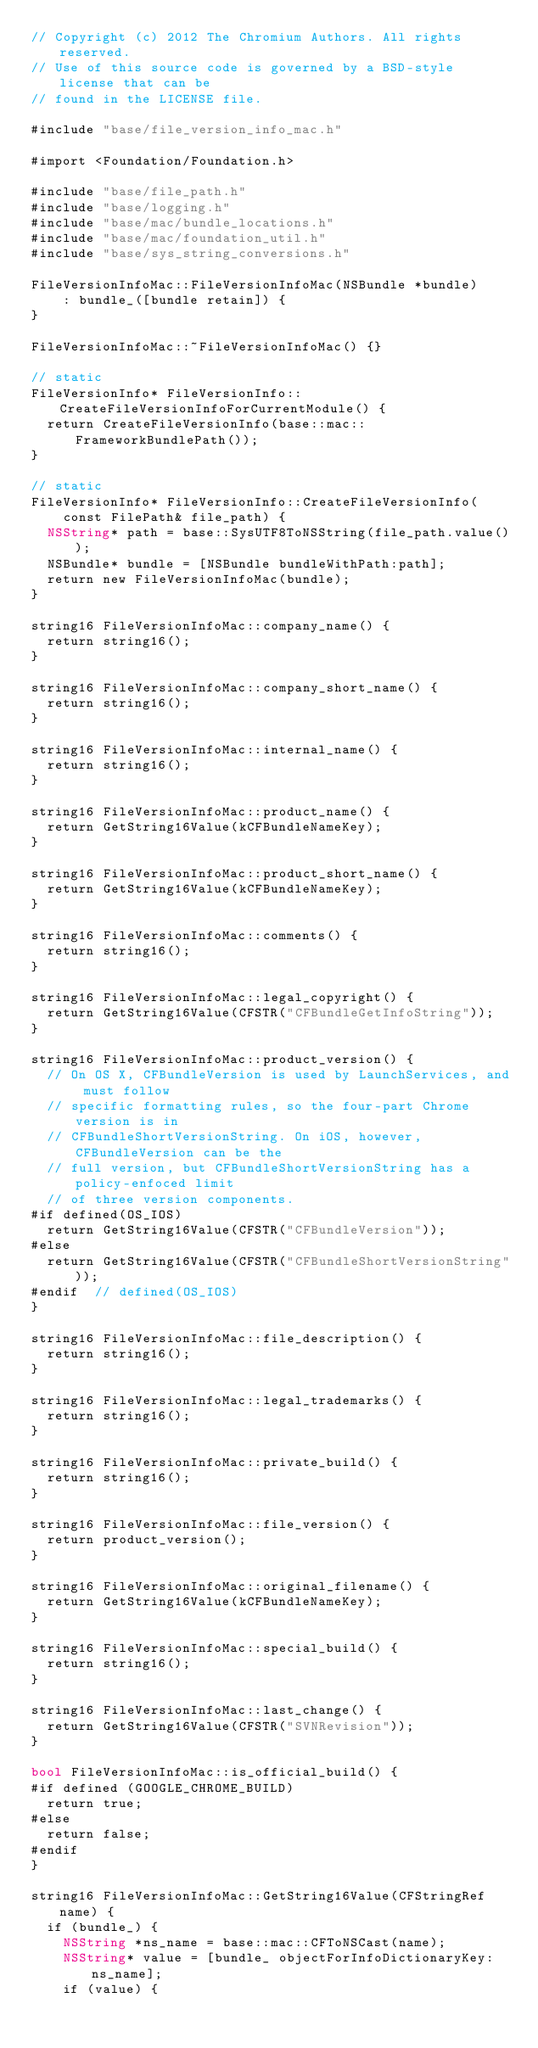Convert code to text. <code><loc_0><loc_0><loc_500><loc_500><_ObjectiveC_>// Copyright (c) 2012 The Chromium Authors. All rights reserved.
// Use of this source code is governed by a BSD-style license that can be
// found in the LICENSE file.

#include "base/file_version_info_mac.h"

#import <Foundation/Foundation.h>

#include "base/file_path.h"
#include "base/logging.h"
#include "base/mac/bundle_locations.h"
#include "base/mac/foundation_util.h"
#include "base/sys_string_conversions.h"

FileVersionInfoMac::FileVersionInfoMac(NSBundle *bundle)
    : bundle_([bundle retain]) {
}

FileVersionInfoMac::~FileVersionInfoMac() {}

// static
FileVersionInfo* FileVersionInfo::CreateFileVersionInfoForCurrentModule() {
  return CreateFileVersionInfo(base::mac::FrameworkBundlePath());
}

// static
FileVersionInfo* FileVersionInfo::CreateFileVersionInfo(
    const FilePath& file_path) {
  NSString* path = base::SysUTF8ToNSString(file_path.value());
  NSBundle* bundle = [NSBundle bundleWithPath:path];
  return new FileVersionInfoMac(bundle);
}

string16 FileVersionInfoMac::company_name() {
  return string16();
}

string16 FileVersionInfoMac::company_short_name() {
  return string16();
}

string16 FileVersionInfoMac::internal_name() {
  return string16();
}

string16 FileVersionInfoMac::product_name() {
  return GetString16Value(kCFBundleNameKey);
}

string16 FileVersionInfoMac::product_short_name() {
  return GetString16Value(kCFBundleNameKey);
}

string16 FileVersionInfoMac::comments() {
  return string16();
}

string16 FileVersionInfoMac::legal_copyright() {
  return GetString16Value(CFSTR("CFBundleGetInfoString"));
}

string16 FileVersionInfoMac::product_version() {
  // On OS X, CFBundleVersion is used by LaunchServices, and must follow
  // specific formatting rules, so the four-part Chrome version is in
  // CFBundleShortVersionString. On iOS, however, CFBundleVersion can be the
  // full version, but CFBundleShortVersionString has a policy-enfoced limit
  // of three version components.
#if defined(OS_IOS)
  return GetString16Value(CFSTR("CFBundleVersion"));
#else
  return GetString16Value(CFSTR("CFBundleShortVersionString"));
#endif  // defined(OS_IOS)
}

string16 FileVersionInfoMac::file_description() {
  return string16();
}

string16 FileVersionInfoMac::legal_trademarks() {
  return string16();
}

string16 FileVersionInfoMac::private_build() {
  return string16();
}

string16 FileVersionInfoMac::file_version() {
  return product_version();
}

string16 FileVersionInfoMac::original_filename() {
  return GetString16Value(kCFBundleNameKey);
}

string16 FileVersionInfoMac::special_build() {
  return string16();
}

string16 FileVersionInfoMac::last_change() {
  return GetString16Value(CFSTR("SVNRevision"));
}

bool FileVersionInfoMac::is_official_build() {
#if defined (GOOGLE_CHROME_BUILD)
  return true;
#else
  return false;
#endif
}

string16 FileVersionInfoMac::GetString16Value(CFStringRef name) {
  if (bundle_) {
    NSString *ns_name = base::mac::CFToNSCast(name);
    NSString* value = [bundle_ objectForInfoDictionaryKey:ns_name];
    if (value) {</code> 